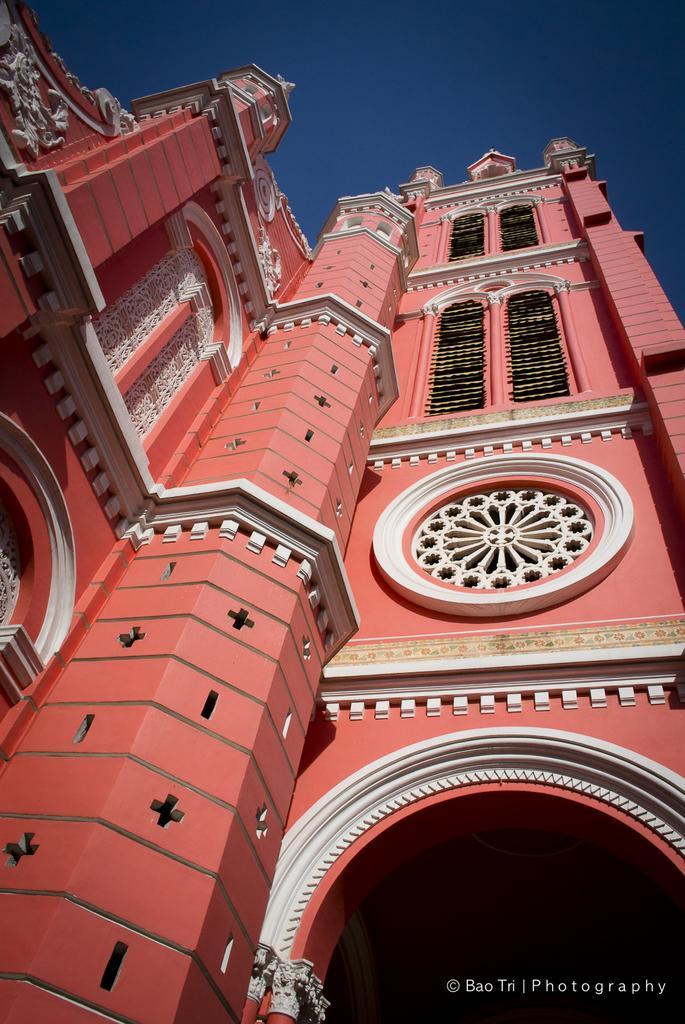How would you summarize this image in a sentence or two? In this image I can see a huge building which is red, white and black in color. In the background I can see the sky. 